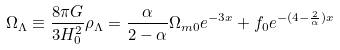<formula> <loc_0><loc_0><loc_500><loc_500>\Omega _ { \Lambda } \equiv \frac { 8 \pi G } { 3 H ^ { 2 } _ { 0 } } \rho _ { \Lambda } = \frac { \alpha } { 2 - \alpha } \Omega _ { m 0 } e ^ { - 3 x } + f _ { 0 } e ^ { - ( 4 - \frac { 2 } { \alpha } ) x }</formula> 